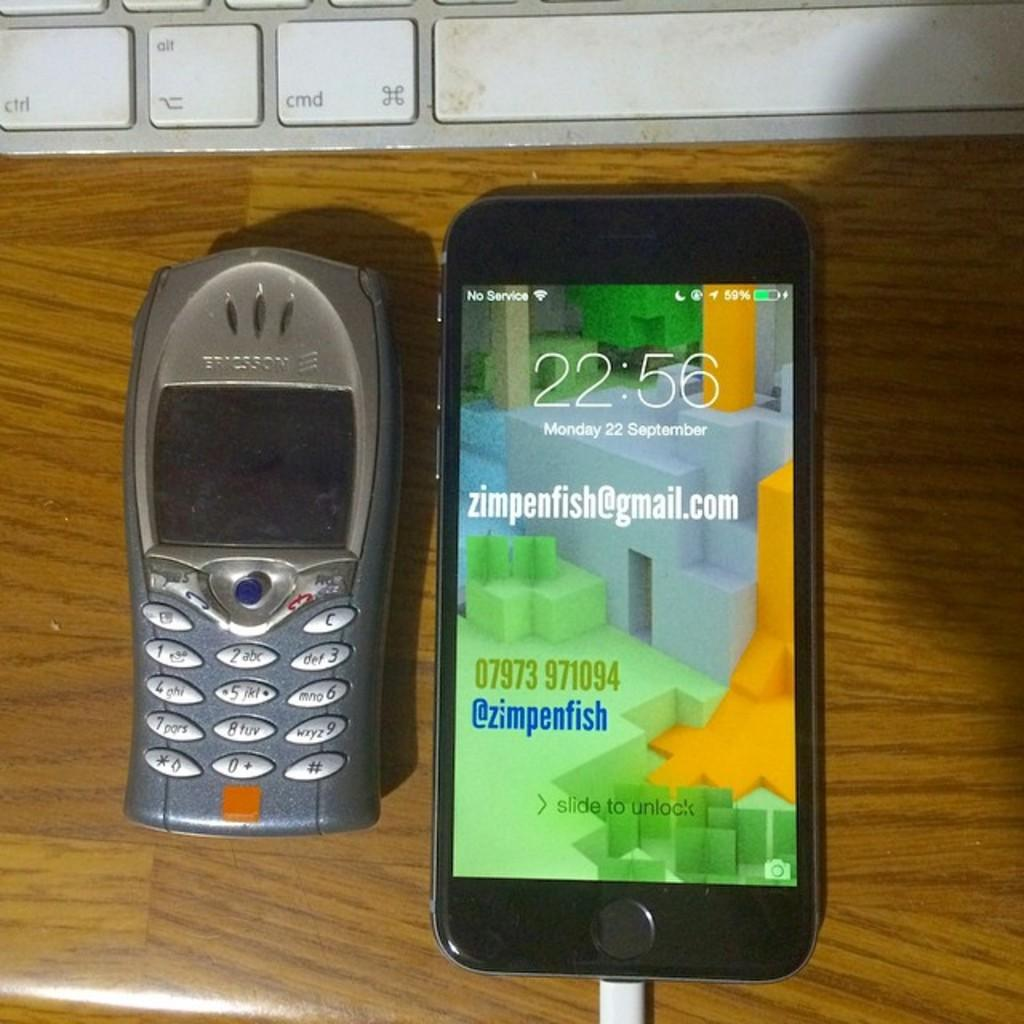<image>
Share a concise interpretation of the image provided. an older version of a cell phone placed next to a new phone with a screen showing a zimpenfish@gmail.com 